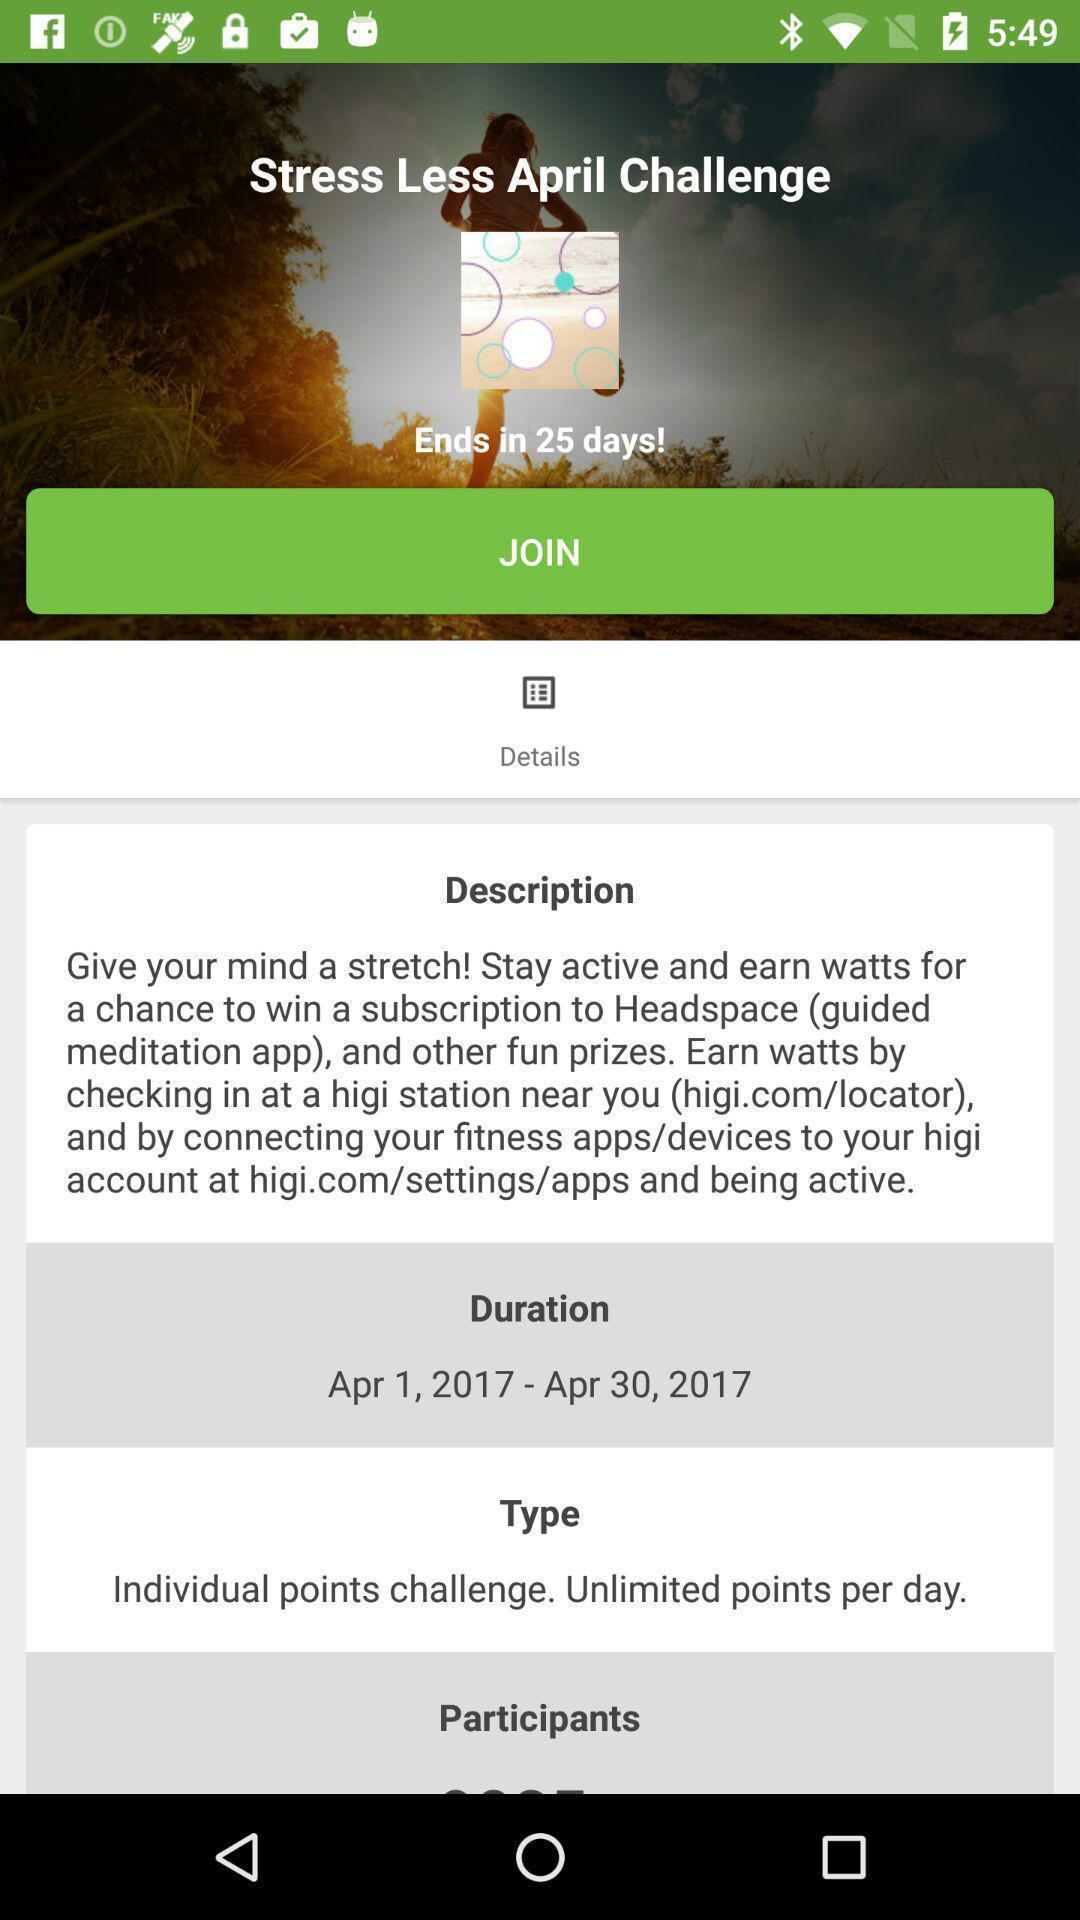What is the overall content of this screenshot? Window displaying a health app. 